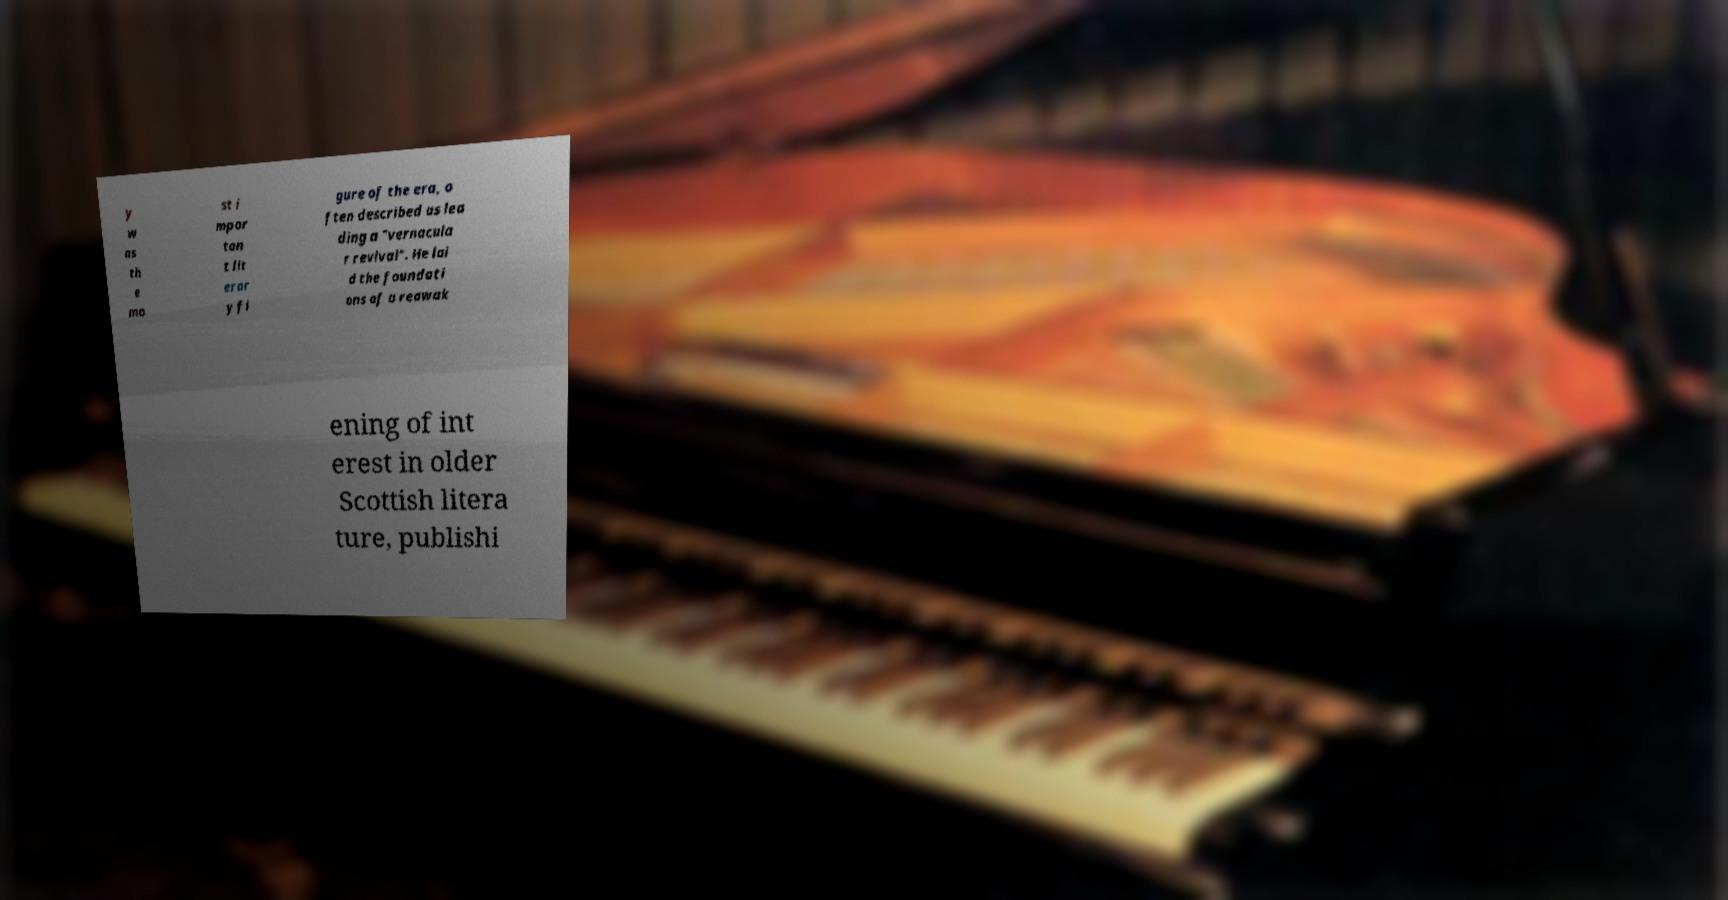There's text embedded in this image that I need extracted. Can you transcribe it verbatim? y w as th e mo st i mpor tan t lit erar y fi gure of the era, o ften described as lea ding a "vernacula r revival". He lai d the foundati ons of a reawak ening of int erest in older Scottish litera ture, publishi 